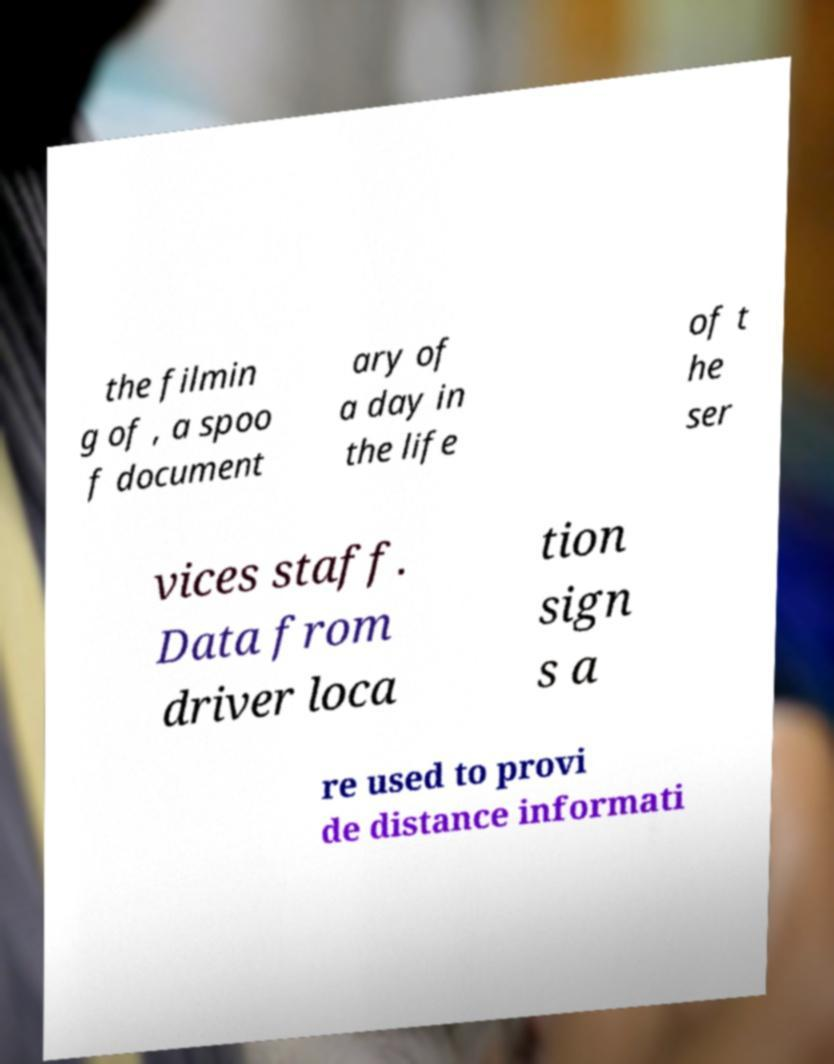Can you read and provide the text displayed in the image?This photo seems to have some interesting text. Can you extract and type it out for me? the filmin g of , a spoo f document ary of a day in the life of t he ser vices staff. Data from driver loca tion sign s a re used to provi de distance informati 